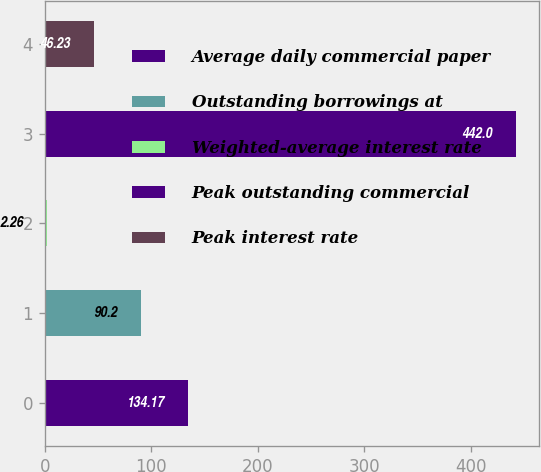<chart> <loc_0><loc_0><loc_500><loc_500><bar_chart><fcel>Average daily commercial paper<fcel>Outstanding borrowings at<fcel>Weighted-average interest rate<fcel>Peak outstanding commercial<fcel>Peak interest rate<nl><fcel>134.17<fcel>90.2<fcel>2.26<fcel>442<fcel>46.23<nl></chart> 